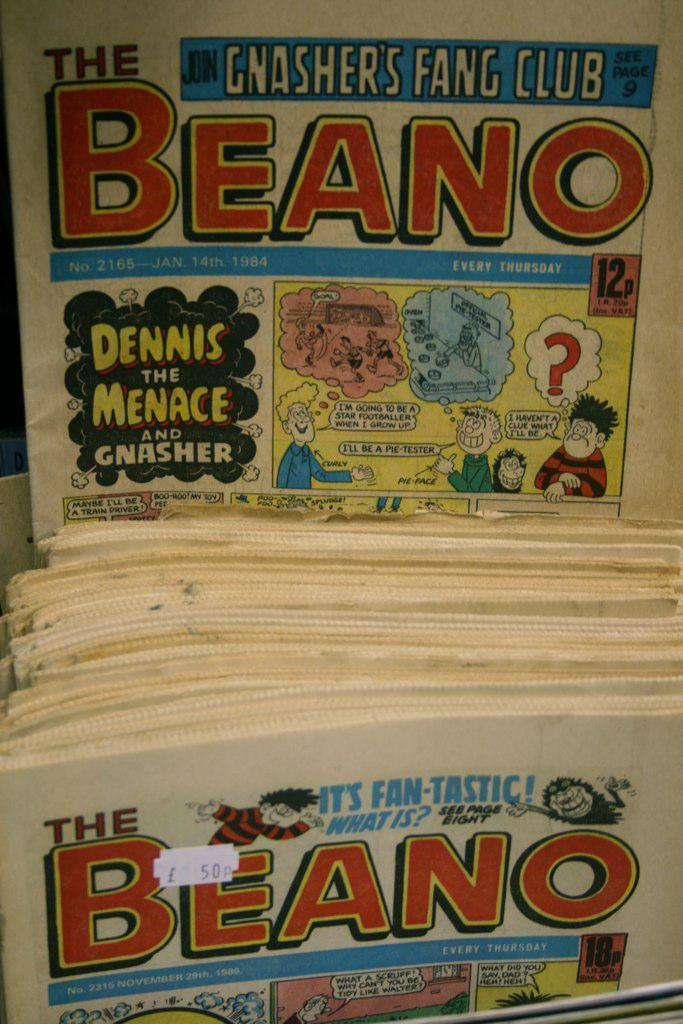<image>
Create a compact narrative representing the image presented. A newspaper called the Beano that features Dennis the Menace comics. 